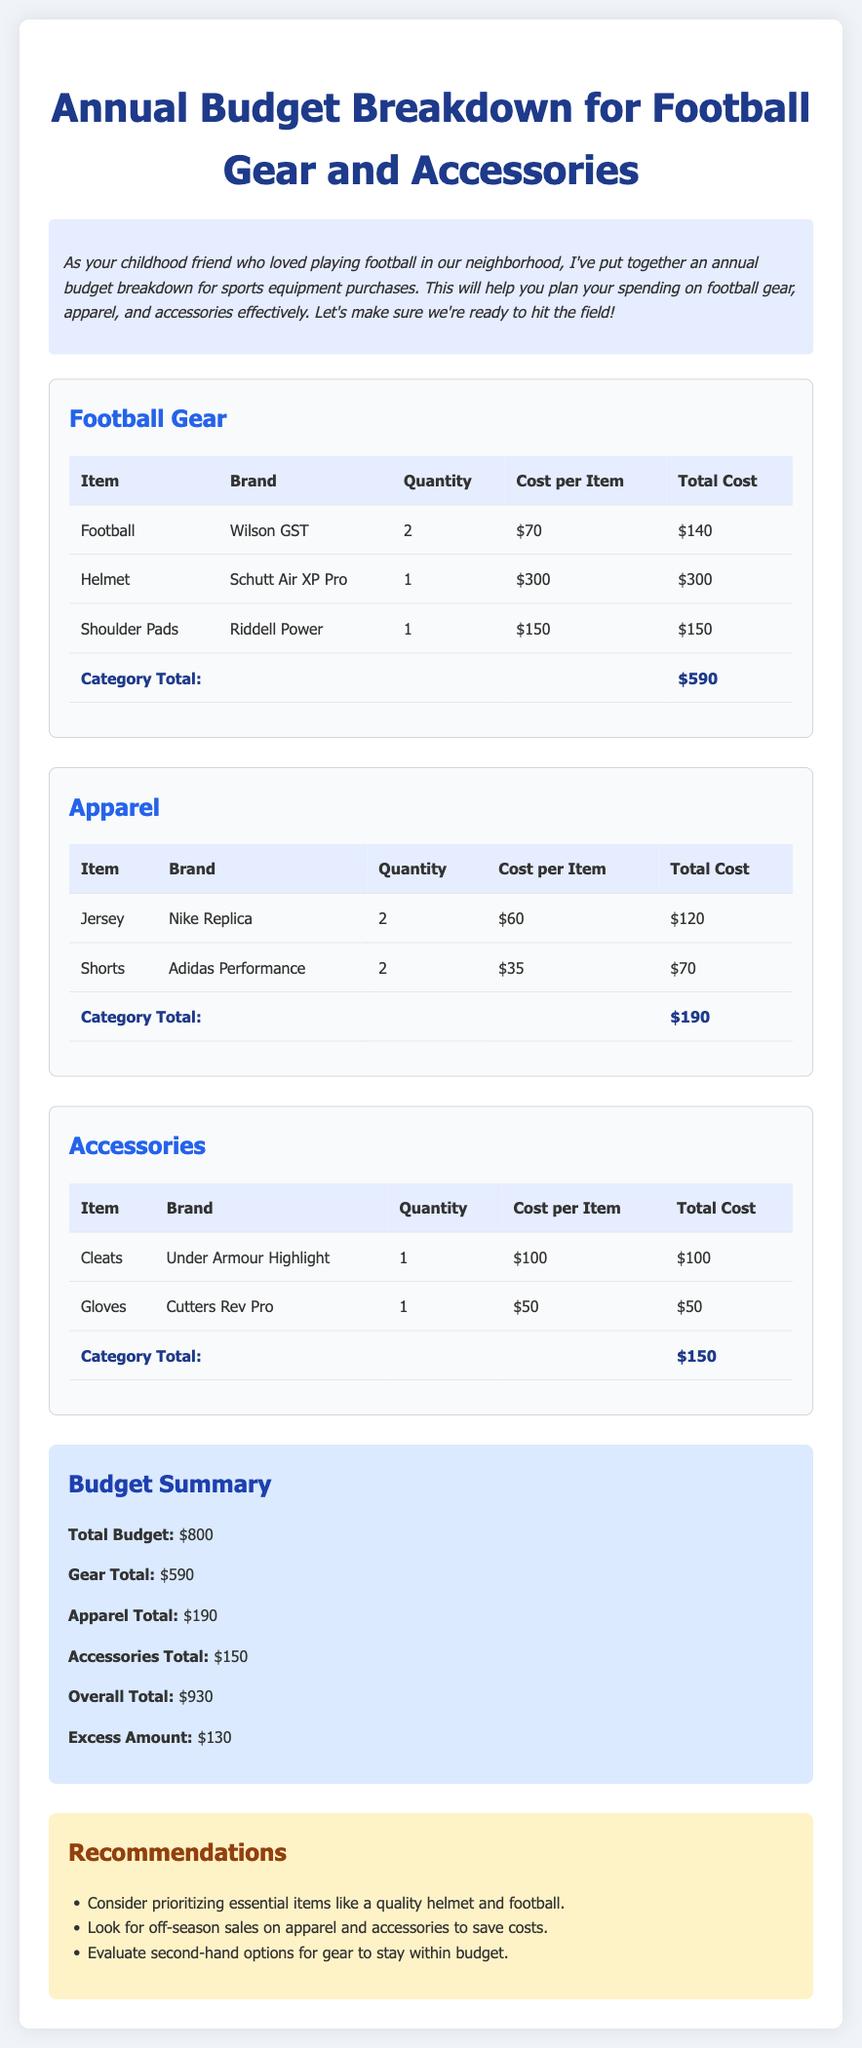What is the total cost for football gear? The total cost for football gear is calculated from the individual costs listed in the football gear table, which adds up to $590.
Answer: $590 How many jerseys are included in the apparel section? The apparel section lists 2 jerseys under the item quantity, confirming that there are 2 jerseys.
Answer: 2 What brand of cleats is listed in the accessories? The accessories list includes cleats from the brand Under Armour Highlight, providing the specific brand name.
Answer: Under Armour Highlight What is the excess amount over the budget? The document states that the overall total exceeds the budget by an excess amount of $130.
Answer: $130 How much did the shoulder pads cost? The shoulder pads listed in the football gear section have a cost of $150, indicating their purchase price.
Answer: $150 What is the total cost for apparel? The total cost for apparel is provided in the document as $190, summarizing the apparel expenses.
Answer: $190 What is the brand of the gloves mentioned in the accessories? The accessories section specifies the brand of gloves as Cutters Rev Pro, explicitly naming the brand.
Answer: Cutters Rev Pro What is the overall total for all categories combined? The overall total sums all the costs from gear, apparel, and accessories, which is stated as $930.
Answer: $930 How many pairs of shoulder pads were purchased? The detailed list indicates that only 1 pair of shoulder pads was purchased in the gear section.
Answer: 1 